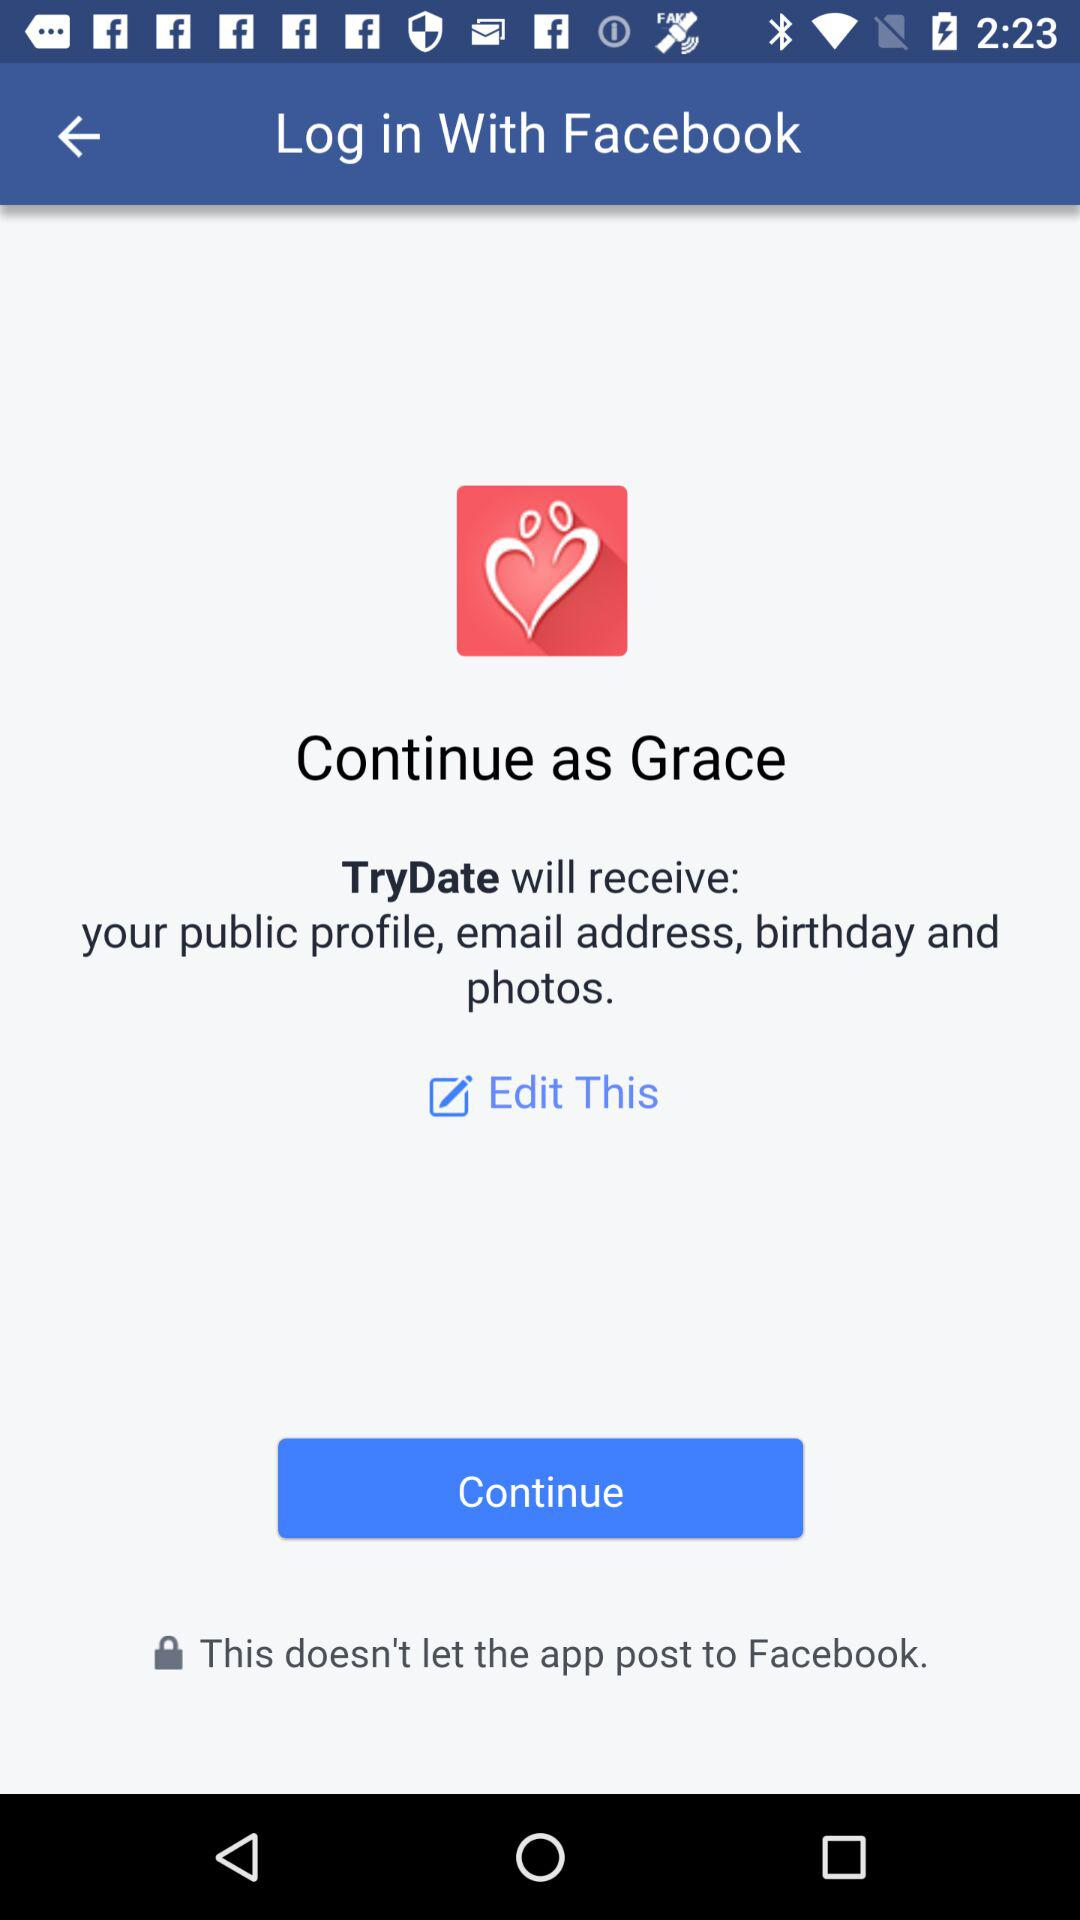What application is asking for permissions? The application is "TryDate". 